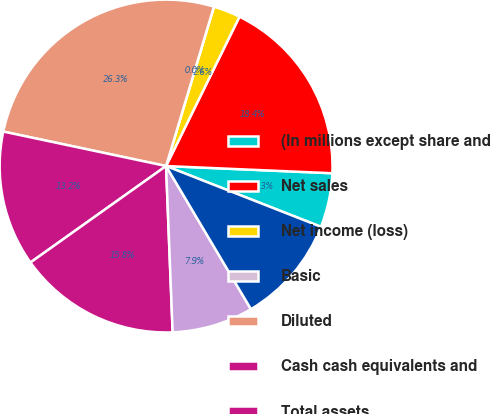Convert chart. <chart><loc_0><loc_0><loc_500><loc_500><pie_chart><fcel>(In millions except share and<fcel>Net sales<fcel>Net income (loss)<fcel>Basic<fcel>Diluted<fcel>Cash cash equivalents and<fcel>Total assets<fcel>Total liabilities<fcel>Shareholders' equity<nl><fcel>5.26%<fcel>18.42%<fcel>2.63%<fcel>0.0%<fcel>26.32%<fcel>13.16%<fcel>15.79%<fcel>7.89%<fcel>10.53%<nl></chart> 